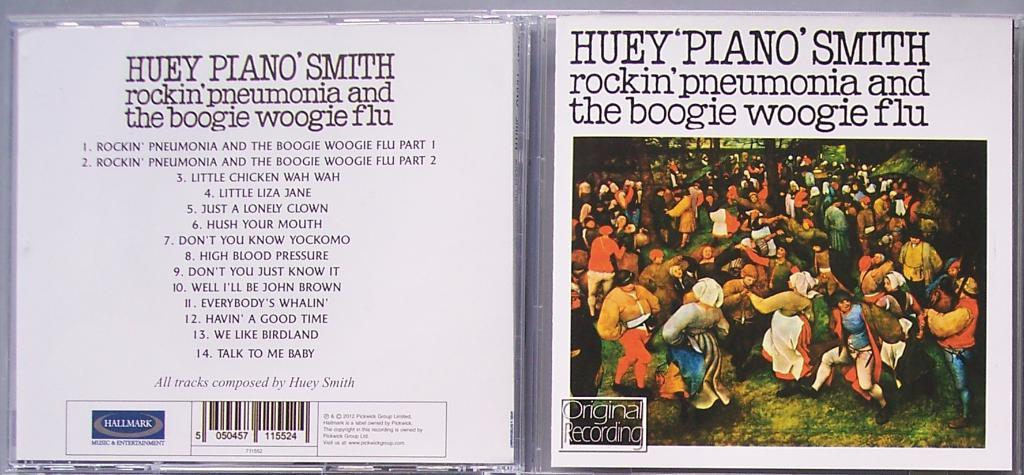What is the main subject of the image? The main subject of the image is a group of people standing on the ground. What can be seen in the background of the image? There are trees visible in the image. Is there any text present in the image? Yes, there is text present on a surface in the image. What type of creature is sitting on the text in the image? There is no creature present in the image, and therefore no creature is sitting on the text. Can you tell me what kind of berries are growing on the trees in the image? There are no berries mentioned or visible in the image; only trees are present. 